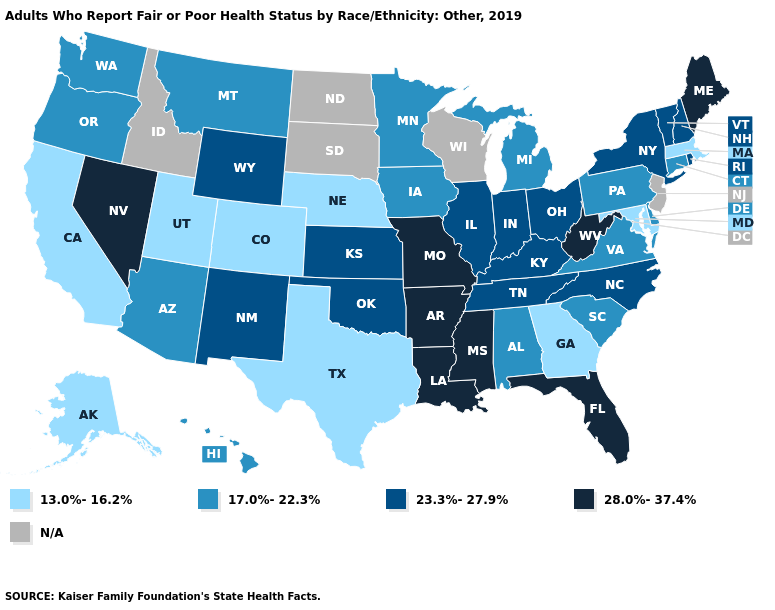Does Washington have the highest value in the USA?
Keep it brief. No. What is the lowest value in the Northeast?
Give a very brief answer. 13.0%-16.2%. Does the first symbol in the legend represent the smallest category?
Give a very brief answer. Yes. Which states have the lowest value in the USA?
Short answer required. Alaska, California, Colorado, Georgia, Maryland, Massachusetts, Nebraska, Texas, Utah. What is the value of Illinois?
Concise answer only. 23.3%-27.9%. Does Arkansas have the highest value in the USA?
Quick response, please. Yes. What is the value of Pennsylvania?
Answer briefly. 17.0%-22.3%. What is the value of Alaska?
Give a very brief answer. 13.0%-16.2%. Name the states that have a value in the range 23.3%-27.9%?
Quick response, please. Illinois, Indiana, Kansas, Kentucky, New Hampshire, New Mexico, New York, North Carolina, Ohio, Oklahoma, Rhode Island, Tennessee, Vermont, Wyoming. How many symbols are there in the legend?
Answer briefly. 5. Does the map have missing data?
Concise answer only. Yes. Does the map have missing data?
Write a very short answer. Yes. 